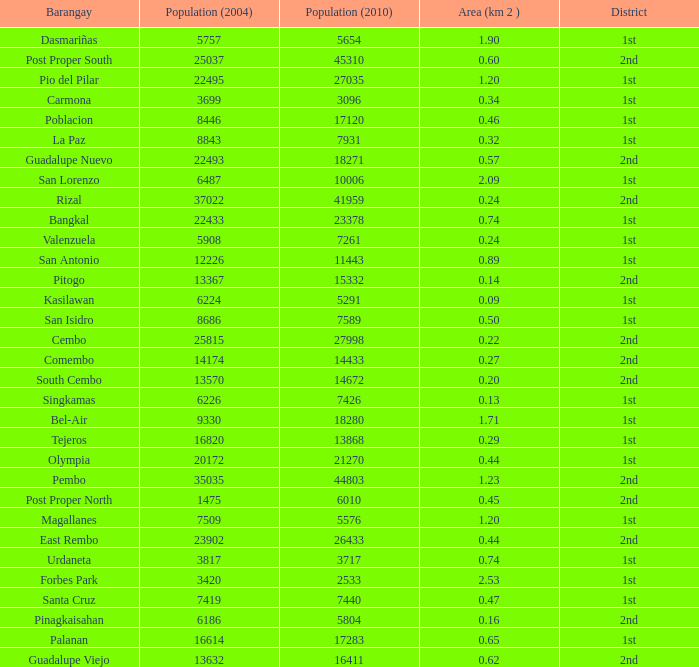What is the area where barangay is guadalupe viejo? 0.62. 